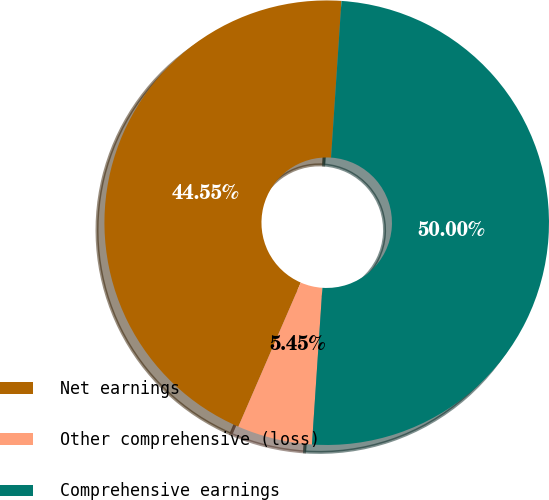Convert chart to OTSL. <chart><loc_0><loc_0><loc_500><loc_500><pie_chart><fcel>Net earnings<fcel>Other comprehensive (loss)<fcel>Comprehensive earnings<nl><fcel>44.55%<fcel>5.45%<fcel>50.0%<nl></chart> 